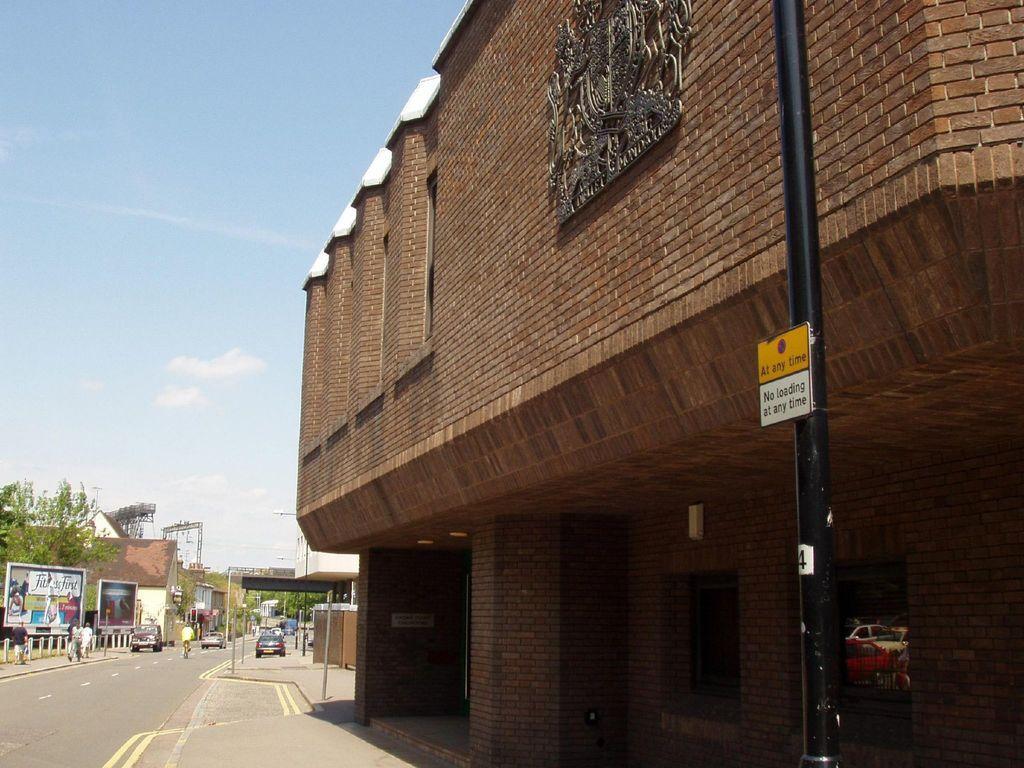Can you describe this image briefly? In this picture I can see some vehicles on the road, side few people are walking and also I can see few banners, trees and buildings. 